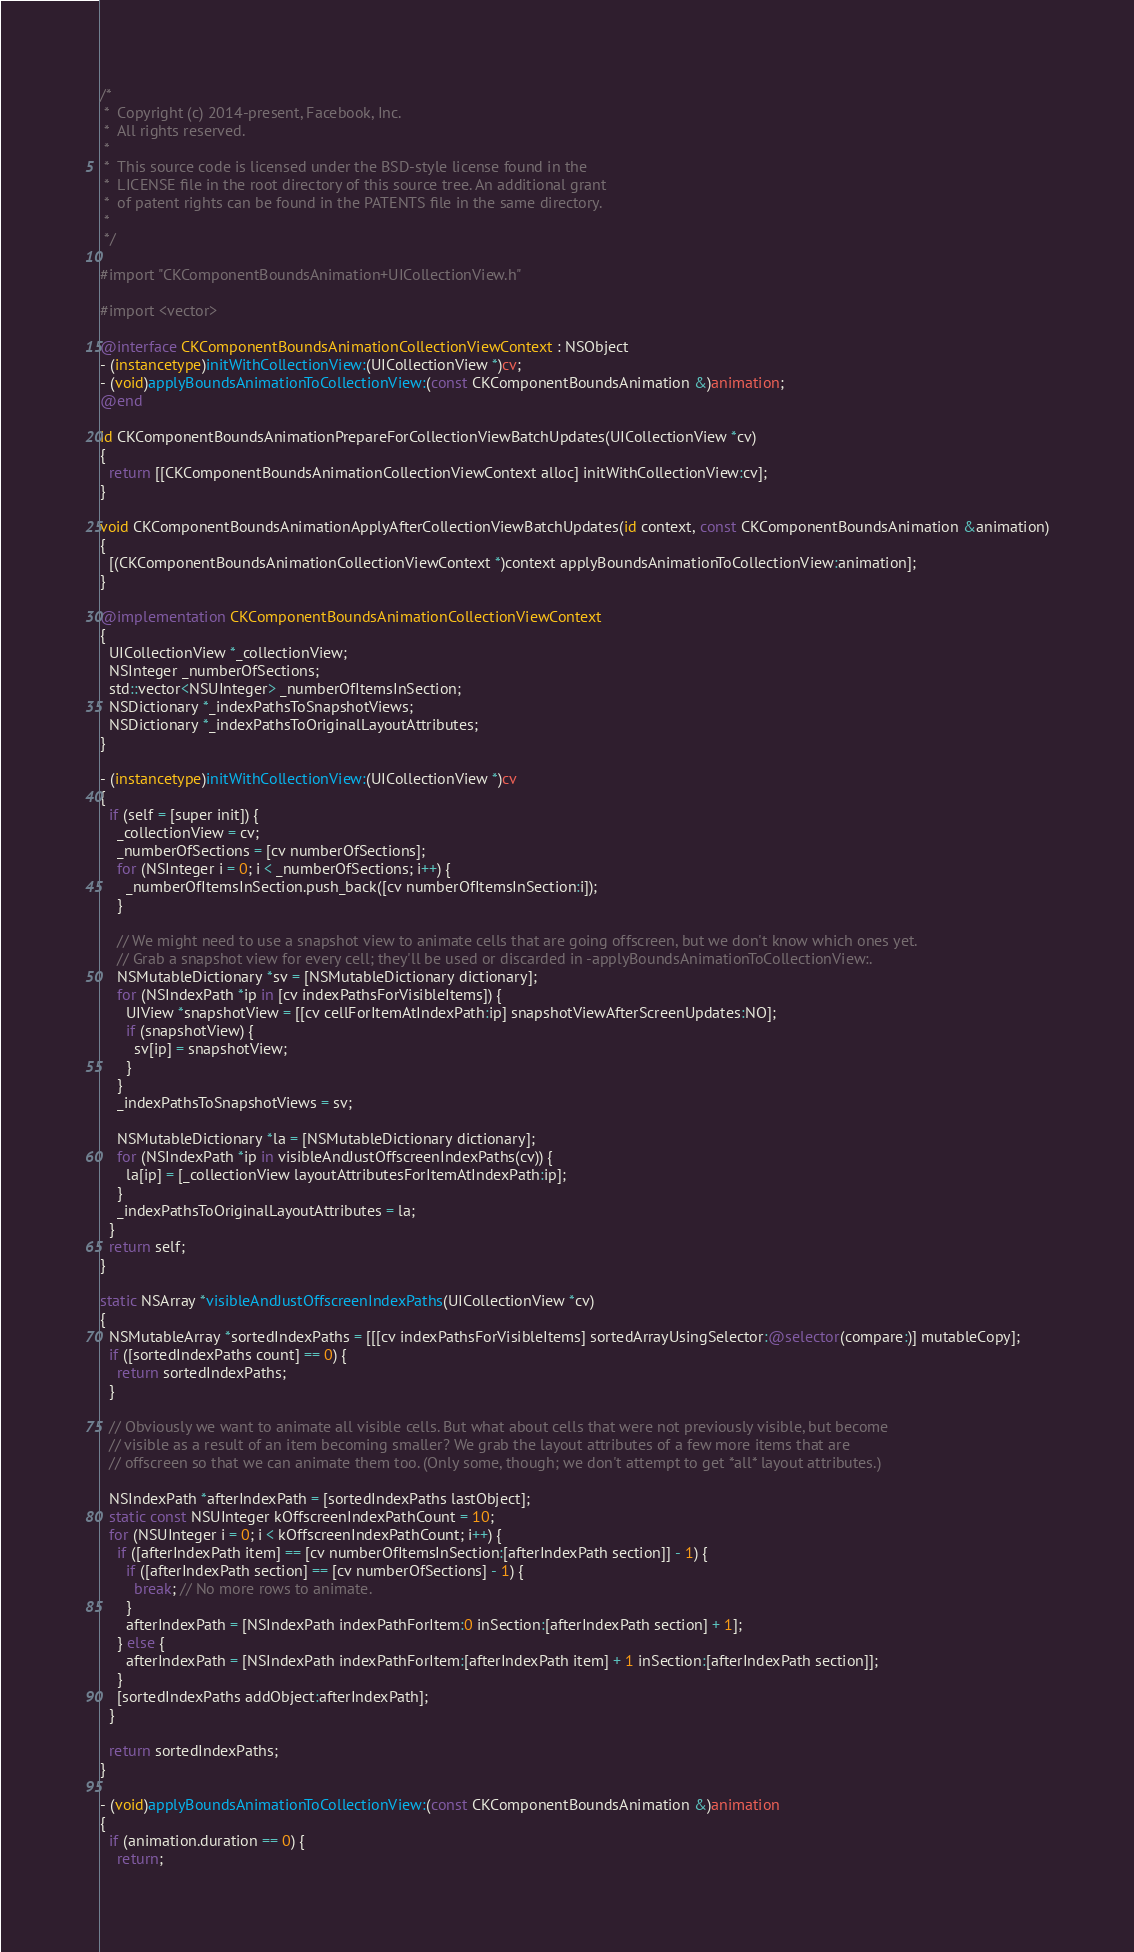<code> <loc_0><loc_0><loc_500><loc_500><_ObjectiveC_>/*
 *  Copyright (c) 2014-present, Facebook, Inc.
 *  All rights reserved.
 *
 *  This source code is licensed under the BSD-style license found in the
 *  LICENSE file in the root directory of this source tree. An additional grant 
 *  of patent rights can be found in the PATENTS file in the same directory.
 *
 */

#import "CKComponentBoundsAnimation+UICollectionView.h"

#import <vector>

@interface CKComponentBoundsAnimationCollectionViewContext : NSObject
- (instancetype)initWithCollectionView:(UICollectionView *)cv;
- (void)applyBoundsAnimationToCollectionView:(const CKComponentBoundsAnimation &)animation;
@end

id CKComponentBoundsAnimationPrepareForCollectionViewBatchUpdates(UICollectionView *cv)
{
  return [[CKComponentBoundsAnimationCollectionViewContext alloc] initWithCollectionView:cv];
}

void CKComponentBoundsAnimationApplyAfterCollectionViewBatchUpdates(id context, const CKComponentBoundsAnimation &animation)
{
  [(CKComponentBoundsAnimationCollectionViewContext *)context applyBoundsAnimationToCollectionView:animation];
}

@implementation CKComponentBoundsAnimationCollectionViewContext
{
  UICollectionView *_collectionView;
  NSInteger _numberOfSections;
  std::vector<NSUInteger> _numberOfItemsInSection;
  NSDictionary *_indexPathsToSnapshotViews;
  NSDictionary *_indexPathsToOriginalLayoutAttributes;
}

- (instancetype)initWithCollectionView:(UICollectionView *)cv
{
  if (self = [super init]) {
    _collectionView = cv;
    _numberOfSections = [cv numberOfSections];
    for (NSInteger i = 0; i < _numberOfSections; i++) {
      _numberOfItemsInSection.push_back([cv numberOfItemsInSection:i]);
    }

    // We might need to use a snapshot view to animate cells that are going offscreen, but we don't know which ones yet.
    // Grab a snapshot view for every cell; they'll be used or discarded in -applyBoundsAnimationToCollectionView:.
    NSMutableDictionary *sv = [NSMutableDictionary dictionary];
    for (NSIndexPath *ip in [cv indexPathsForVisibleItems]) {
      UIView *snapshotView = [[cv cellForItemAtIndexPath:ip] snapshotViewAfterScreenUpdates:NO];
      if (snapshotView) {
        sv[ip] = snapshotView;
      }
    }
    _indexPathsToSnapshotViews = sv;

    NSMutableDictionary *la = [NSMutableDictionary dictionary];
    for (NSIndexPath *ip in visibleAndJustOffscreenIndexPaths(cv)) {
      la[ip] = [_collectionView layoutAttributesForItemAtIndexPath:ip];
    }
    _indexPathsToOriginalLayoutAttributes = la;
  }
  return self;
}

static NSArray *visibleAndJustOffscreenIndexPaths(UICollectionView *cv)
{
  NSMutableArray *sortedIndexPaths = [[[cv indexPathsForVisibleItems] sortedArrayUsingSelector:@selector(compare:)] mutableCopy];
  if ([sortedIndexPaths count] == 0) {
    return sortedIndexPaths;
  }

  // Obviously we want to animate all visible cells. But what about cells that were not previously visible, but become
  // visible as a result of an item becoming smaller? We grab the layout attributes of a few more items that are
  // offscreen so that we can animate them too. (Only some, though; we don't attempt to get *all* layout attributes.)

  NSIndexPath *afterIndexPath = [sortedIndexPaths lastObject];
  static const NSUInteger kOffscreenIndexPathCount = 10;
  for (NSUInteger i = 0; i < kOffscreenIndexPathCount; i++) {
    if ([afterIndexPath item] == [cv numberOfItemsInSection:[afterIndexPath section]] - 1) {
      if ([afterIndexPath section] == [cv numberOfSections] - 1) {
        break; // No more rows to animate.
      }
      afterIndexPath = [NSIndexPath indexPathForItem:0 inSection:[afterIndexPath section] + 1];
    } else {
      afterIndexPath = [NSIndexPath indexPathForItem:[afterIndexPath item] + 1 inSection:[afterIndexPath section]];
    }
    [sortedIndexPaths addObject:afterIndexPath];
  }

  return sortedIndexPaths;
}

- (void)applyBoundsAnimationToCollectionView:(const CKComponentBoundsAnimation &)animation
{
  if (animation.duration == 0) {
    return;</code> 